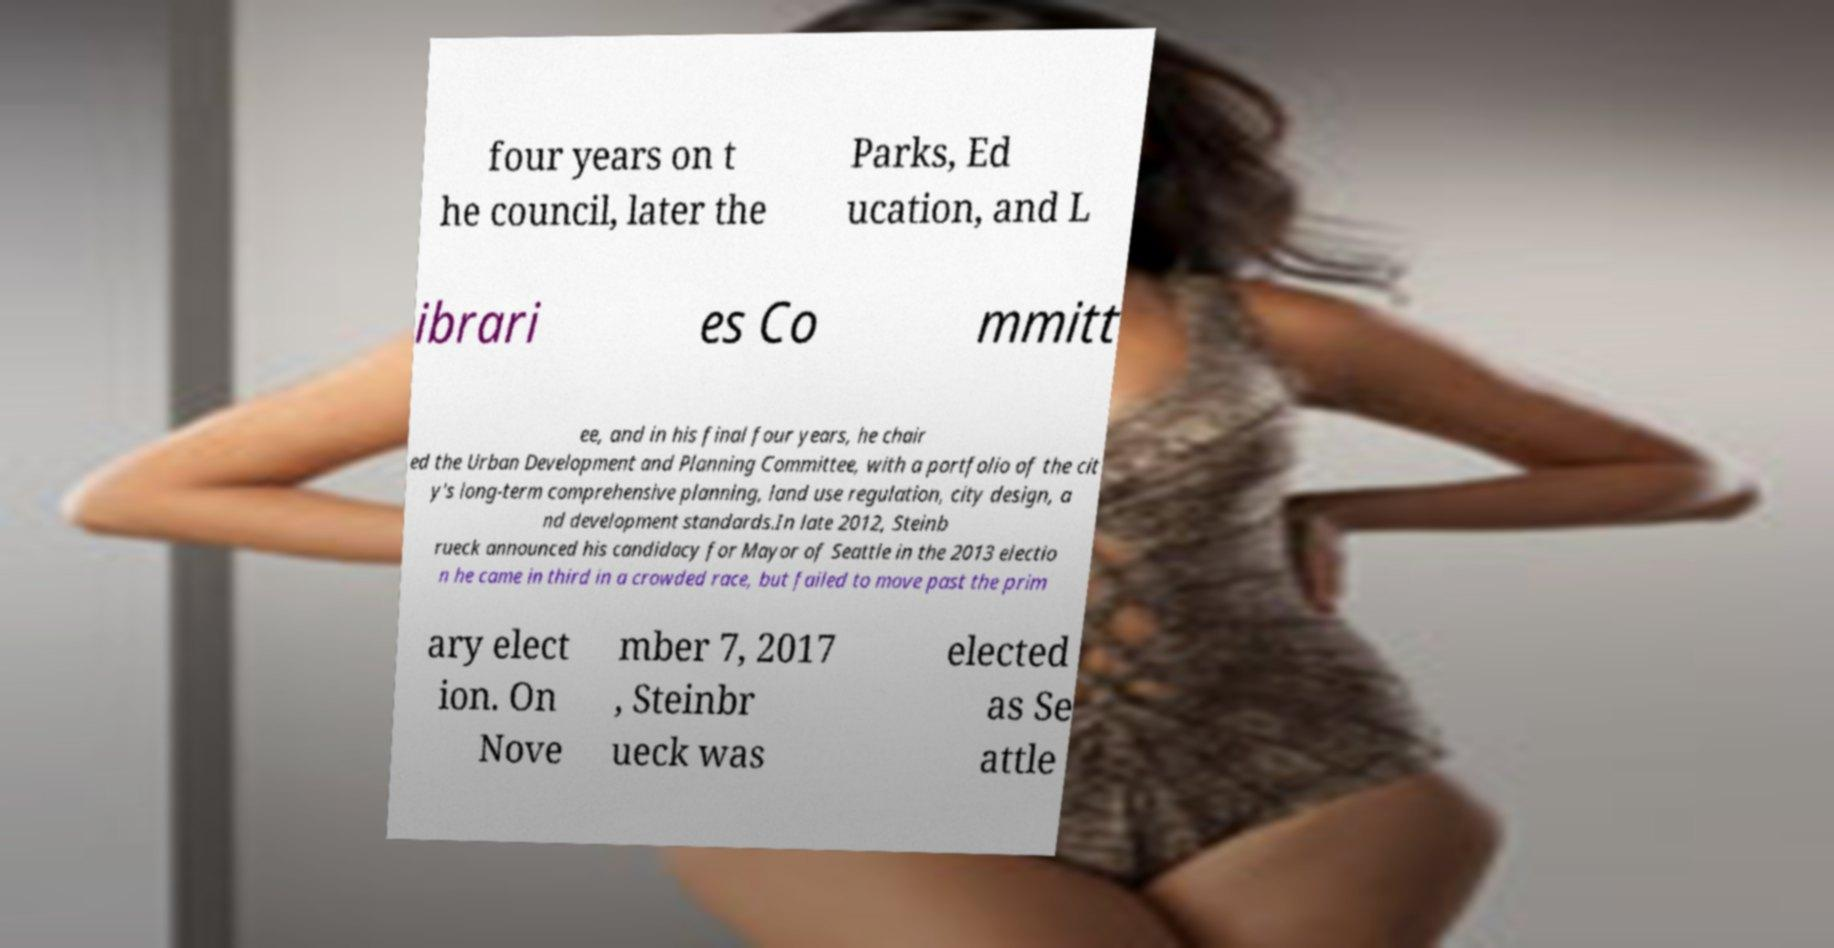I need the written content from this picture converted into text. Can you do that? four years on t he council, later the Parks, Ed ucation, and L ibrari es Co mmitt ee, and in his final four years, he chair ed the Urban Development and Planning Committee, with a portfolio of the cit y's long-term comprehensive planning, land use regulation, city design, a nd development standards.In late 2012, Steinb rueck announced his candidacy for Mayor of Seattle in the 2013 electio n he came in third in a crowded race, but failed to move past the prim ary elect ion. On Nove mber 7, 2017 , Steinbr ueck was elected as Se attle 